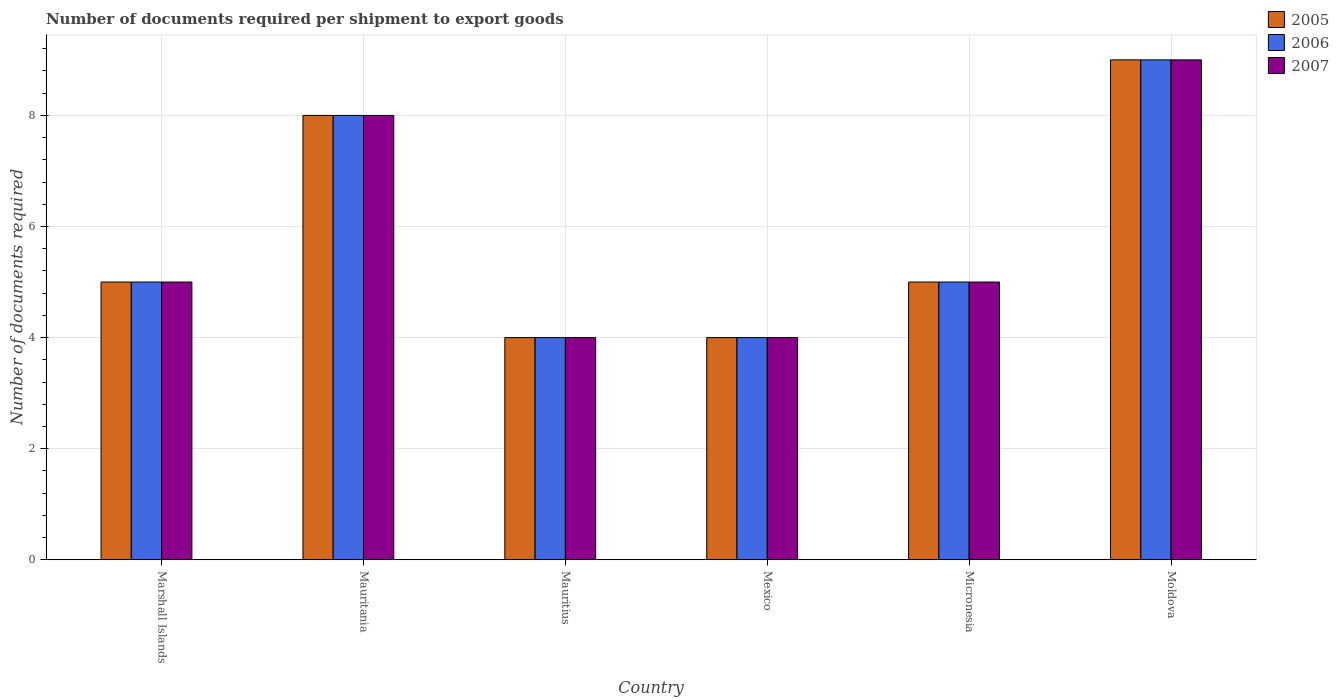How many different coloured bars are there?
Make the answer very short. 3. How many groups of bars are there?
Your answer should be compact. 6. Are the number of bars per tick equal to the number of legend labels?
Give a very brief answer. Yes. How many bars are there on the 4th tick from the right?
Provide a succinct answer. 3. What is the label of the 5th group of bars from the left?
Offer a terse response. Micronesia. In how many cases, is the number of bars for a given country not equal to the number of legend labels?
Your answer should be compact. 0. What is the number of documents required per shipment to export goods in 2007 in Micronesia?
Give a very brief answer. 5. Across all countries, what is the maximum number of documents required per shipment to export goods in 2007?
Give a very brief answer. 9. Across all countries, what is the minimum number of documents required per shipment to export goods in 2006?
Make the answer very short. 4. In which country was the number of documents required per shipment to export goods in 2005 maximum?
Make the answer very short. Moldova. In which country was the number of documents required per shipment to export goods in 2006 minimum?
Ensure brevity in your answer.  Mauritius. What is the difference between the number of documents required per shipment to export goods in 2007 in Mauritania and the number of documents required per shipment to export goods in 2005 in Mexico?
Keep it short and to the point. 4. What is the average number of documents required per shipment to export goods in 2007 per country?
Your answer should be very brief. 5.83. What is the difference between the number of documents required per shipment to export goods of/in 2006 and number of documents required per shipment to export goods of/in 2005 in Mexico?
Your answer should be very brief. 0. In how many countries, is the number of documents required per shipment to export goods in 2005 greater than 2.8?
Offer a terse response. 6. What is the ratio of the number of documents required per shipment to export goods in 2005 in Mauritius to that in Moldova?
Your answer should be compact. 0.44. Is the number of documents required per shipment to export goods in 2006 in Marshall Islands less than that in Micronesia?
Provide a short and direct response. No. Is the difference between the number of documents required per shipment to export goods in 2006 in Micronesia and Moldova greater than the difference between the number of documents required per shipment to export goods in 2005 in Micronesia and Moldova?
Keep it short and to the point. No. Is the sum of the number of documents required per shipment to export goods in 2007 in Micronesia and Moldova greater than the maximum number of documents required per shipment to export goods in 2006 across all countries?
Offer a very short reply. Yes. What does the 1st bar from the right in Micronesia represents?
Your answer should be compact. 2007. How many bars are there?
Your answer should be very brief. 18. What is the difference between two consecutive major ticks on the Y-axis?
Ensure brevity in your answer.  2. Does the graph contain any zero values?
Give a very brief answer. No. Does the graph contain grids?
Offer a terse response. Yes. Where does the legend appear in the graph?
Your answer should be very brief. Top right. What is the title of the graph?
Keep it short and to the point. Number of documents required per shipment to export goods. Does "1980" appear as one of the legend labels in the graph?
Provide a short and direct response. No. What is the label or title of the Y-axis?
Provide a short and direct response. Number of documents required. What is the Number of documents required in 2006 in Mauritius?
Offer a terse response. 4. What is the Number of documents required in 2005 in Mexico?
Ensure brevity in your answer.  4. What is the Number of documents required in 2006 in Mexico?
Ensure brevity in your answer.  4. What is the Number of documents required in 2007 in Mexico?
Ensure brevity in your answer.  4. What is the Number of documents required of 2005 in Moldova?
Ensure brevity in your answer.  9. What is the Number of documents required of 2006 in Moldova?
Provide a short and direct response. 9. What is the Number of documents required in 2007 in Moldova?
Provide a succinct answer. 9. Across all countries, what is the maximum Number of documents required in 2006?
Ensure brevity in your answer.  9. What is the total Number of documents required in 2007 in the graph?
Keep it short and to the point. 35. What is the difference between the Number of documents required in 2007 in Marshall Islands and that in Mauritania?
Offer a terse response. -3. What is the difference between the Number of documents required in 2005 in Marshall Islands and that in Mauritius?
Make the answer very short. 1. What is the difference between the Number of documents required in 2006 in Marshall Islands and that in Mauritius?
Give a very brief answer. 1. What is the difference between the Number of documents required of 2006 in Marshall Islands and that in Micronesia?
Your response must be concise. 0. What is the difference between the Number of documents required of 2005 in Marshall Islands and that in Moldova?
Offer a terse response. -4. What is the difference between the Number of documents required in 2006 in Marshall Islands and that in Moldova?
Offer a very short reply. -4. What is the difference between the Number of documents required in 2007 in Marshall Islands and that in Moldova?
Your answer should be compact. -4. What is the difference between the Number of documents required in 2006 in Mauritania and that in Mauritius?
Provide a short and direct response. 4. What is the difference between the Number of documents required of 2007 in Mauritania and that in Mauritius?
Ensure brevity in your answer.  4. What is the difference between the Number of documents required in 2006 in Mauritania and that in Mexico?
Provide a short and direct response. 4. What is the difference between the Number of documents required of 2005 in Mauritania and that in Micronesia?
Give a very brief answer. 3. What is the difference between the Number of documents required of 2007 in Mauritania and that in Micronesia?
Make the answer very short. 3. What is the difference between the Number of documents required in 2005 in Mauritania and that in Moldova?
Offer a very short reply. -1. What is the difference between the Number of documents required in 2007 in Mauritania and that in Moldova?
Offer a very short reply. -1. What is the difference between the Number of documents required of 2005 in Mauritius and that in Mexico?
Give a very brief answer. 0. What is the difference between the Number of documents required in 2006 in Mauritius and that in Mexico?
Offer a terse response. 0. What is the difference between the Number of documents required in 2005 in Mauritius and that in Micronesia?
Your response must be concise. -1. What is the difference between the Number of documents required in 2006 in Mauritius and that in Micronesia?
Offer a terse response. -1. What is the difference between the Number of documents required of 2007 in Mauritius and that in Micronesia?
Offer a terse response. -1. What is the difference between the Number of documents required of 2005 in Mauritius and that in Moldova?
Ensure brevity in your answer.  -5. What is the difference between the Number of documents required of 2006 in Mexico and that in Micronesia?
Provide a succinct answer. -1. What is the difference between the Number of documents required of 2005 in Mexico and that in Moldova?
Offer a terse response. -5. What is the difference between the Number of documents required of 2007 in Mexico and that in Moldova?
Offer a terse response. -5. What is the difference between the Number of documents required of 2005 in Micronesia and that in Moldova?
Provide a short and direct response. -4. What is the difference between the Number of documents required of 2005 in Marshall Islands and the Number of documents required of 2006 in Mauritania?
Keep it short and to the point. -3. What is the difference between the Number of documents required of 2005 in Marshall Islands and the Number of documents required of 2006 in Mauritius?
Keep it short and to the point. 1. What is the difference between the Number of documents required in 2005 in Marshall Islands and the Number of documents required in 2007 in Mauritius?
Provide a succinct answer. 1. What is the difference between the Number of documents required of 2005 in Marshall Islands and the Number of documents required of 2006 in Mexico?
Make the answer very short. 1. What is the difference between the Number of documents required of 2005 in Marshall Islands and the Number of documents required of 2007 in Mexico?
Your answer should be very brief. 1. What is the difference between the Number of documents required of 2005 in Marshall Islands and the Number of documents required of 2006 in Moldova?
Your answer should be very brief. -4. What is the difference between the Number of documents required of 2006 in Marshall Islands and the Number of documents required of 2007 in Moldova?
Your answer should be very brief. -4. What is the difference between the Number of documents required of 2005 in Mauritania and the Number of documents required of 2007 in Mauritius?
Your answer should be very brief. 4. What is the difference between the Number of documents required of 2006 in Mauritania and the Number of documents required of 2007 in Mauritius?
Provide a short and direct response. 4. What is the difference between the Number of documents required in 2005 in Mauritania and the Number of documents required in 2007 in Mexico?
Provide a short and direct response. 4. What is the difference between the Number of documents required in 2005 in Mauritania and the Number of documents required in 2007 in Micronesia?
Your answer should be compact. 3. What is the difference between the Number of documents required of 2005 in Mauritania and the Number of documents required of 2007 in Moldova?
Your response must be concise. -1. What is the difference between the Number of documents required of 2005 in Mauritius and the Number of documents required of 2006 in Mexico?
Give a very brief answer. 0. What is the difference between the Number of documents required in 2005 in Mauritius and the Number of documents required in 2007 in Mexico?
Offer a terse response. 0. What is the difference between the Number of documents required of 2006 in Mauritius and the Number of documents required of 2007 in Mexico?
Offer a terse response. 0. What is the difference between the Number of documents required in 2005 in Mauritius and the Number of documents required in 2006 in Micronesia?
Make the answer very short. -1. What is the difference between the Number of documents required of 2006 in Mauritius and the Number of documents required of 2007 in Micronesia?
Offer a terse response. -1. What is the difference between the Number of documents required in 2005 in Mauritius and the Number of documents required in 2006 in Moldova?
Make the answer very short. -5. What is the difference between the Number of documents required of 2005 in Mauritius and the Number of documents required of 2007 in Moldova?
Your answer should be compact. -5. What is the difference between the Number of documents required in 2006 in Mauritius and the Number of documents required in 2007 in Moldova?
Provide a succinct answer. -5. What is the difference between the Number of documents required of 2005 in Mexico and the Number of documents required of 2006 in Micronesia?
Make the answer very short. -1. What is the difference between the Number of documents required in 2005 in Mexico and the Number of documents required in 2006 in Moldova?
Give a very brief answer. -5. What is the difference between the Number of documents required in 2005 in Mexico and the Number of documents required in 2007 in Moldova?
Your answer should be compact. -5. What is the difference between the Number of documents required in 2005 in Micronesia and the Number of documents required in 2006 in Moldova?
Offer a terse response. -4. What is the difference between the Number of documents required of 2006 in Micronesia and the Number of documents required of 2007 in Moldova?
Keep it short and to the point. -4. What is the average Number of documents required in 2005 per country?
Your response must be concise. 5.83. What is the average Number of documents required of 2006 per country?
Keep it short and to the point. 5.83. What is the average Number of documents required in 2007 per country?
Your response must be concise. 5.83. What is the difference between the Number of documents required of 2006 and Number of documents required of 2007 in Marshall Islands?
Your answer should be compact. 0. What is the difference between the Number of documents required in 2005 and Number of documents required in 2006 in Mauritania?
Ensure brevity in your answer.  0. What is the difference between the Number of documents required in 2005 and Number of documents required in 2006 in Mauritius?
Provide a short and direct response. 0. What is the difference between the Number of documents required of 2005 and Number of documents required of 2007 in Mauritius?
Ensure brevity in your answer.  0. What is the difference between the Number of documents required in 2005 and Number of documents required in 2007 in Mexico?
Offer a terse response. 0. What is the difference between the Number of documents required of 2005 and Number of documents required of 2006 in Micronesia?
Offer a very short reply. 0. What is the ratio of the Number of documents required in 2007 in Marshall Islands to that in Mauritania?
Provide a succinct answer. 0.62. What is the ratio of the Number of documents required of 2006 in Marshall Islands to that in Mauritius?
Provide a short and direct response. 1.25. What is the ratio of the Number of documents required in 2005 in Marshall Islands to that in Mexico?
Provide a short and direct response. 1.25. What is the ratio of the Number of documents required in 2006 in Marshall Islands to that in Mexico?
Provide a short and direct response. 1.25. What is the ratio of the Number of documents required in 2007 in Marshall Islands to that in Mexico?
Offer a very short reply. 1.25. What is the ratio of the Number of documents required of 2006 in Marshall Islands to that in Micronesia?
Make the answer very short. 1. What is the ratio of the Number of documents required of 2005 in Marshall Islands to that in Moldova?
Offer a very short reply. 0.56. What is the ratio of the Number of documents required in 2006 in Marshall Islands to that in Moldova?
Your answer should be compact. 0.56. What is the ratio of the Number of documents required of 2007 in Marshall Islands to that in Moldova?
Make the answer very short. 0.56. What is the ratio of the Number of documents required of 2005 in Mauritania to that in Mauritius?
Provide a short and direct response. 2. What is the ratio of the Number of documents required in 2006 in Mauritania to that in Mauritius?
Provide a succinct answer. 2. What is the ratio of the Number of documents required of 2005 in Mauritania to that in Mexico?
Provide a succinct answer. 2. What is the ratio of the Number of documents required of 2006 in Mauritania to that in Mexico?
Keep it short and to the point. 2. What is the ratio of the Number of documents required of 2007 in Mauritania to that in Mexico?
Your response must be concise. 2. What is the ratio of the Number of documents required in 2005 in Mauritania to that in Micronesia?
Make the answer very short. 1.6. What is the ratio of the Number of documents required of 2007 in Mauritania to that in Micronesia?
Keep it short and to the point. 1.6. What is the ratio of the Number of documents required of 2005 in Mauritania to that in Moldova?
Your answer should be very brief. 0.89. What is the ratio of the Number of documents required in 2006 in Mauritania to that in Moldova?
Offer a very short reply. 0.89. What is the ratio of the Number of documents required in 2007 in Mauritania to that in Moldova?
Ensure brevity in your answer.  0.89. What is the ratio of the Number of documents required of 2007 in Mauritius to that in Mexico?
Ensure brevity in your answer.  1. What is the ratio of the Number of documents required of 2006 in Mauritius to that in Micronesia?
Make the answer very short. 0.8. What is the ratio of the Number of documents required in 2005 in Mauritius to that in Moldova?
Your answer should be very brief. 0.44. What is the ratio of the Number of documents required of 2006 in Mauritius to that in Moldova?
Make the answer very short. 0.44. What is the ratio of the Number of documents required in 2007 in Mauritius to that in Moldova?
Offer a very short reply. 0.44. What is the ratio of the Number of documents required in 2006 in Mexico to that in Micronesia?
Offer a terse response. 0.8. What is the ratio of the Number of documents required in 2007 in Mexico to that in Micronesia?
Your answer should be compact. 0.8. What is the ratio of the Number of documents required in 2005 in Mexico to that in Moldova?
Offer a terse response. 0.44. What is the ratio of the Number of documents required of 2006 in Mexico to that in Moldova?
Keep it short and to the point. 0.44. What is the ratio of the Number of documents required of 2007 in Mexico to that in Moldova?
Your response must be concise. 0.44. What is the ratio of the Number of documents required of 2005 in Micronesia to that in Moldova?
Your response must be concise. 0.56. What is the ratio of the Number of documents required of 2006 in Micronesia to that in Moldova?
Your response must be concise. 0.56. What is the ratio of the Number of documents required of 2007 in Micronesia to that in Moldova?
Provide a short and direct response. 0.56. What is the difference between the highest and the second highest Number of documents required of 2006?
Provide a short and direct response. 1. What is the difference between the highest and the lowest Number of documents required of 2006?
Keep it short and to the point. 5. 